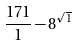Convert formula to latex. <formula><loc_0><loc_0><loc_500><loc_500>\frac { 1 7 1 } { 1 } - 8 ^ { \sqrt { 1 } }</formula> 